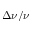<formula> <loc_0><loc_0><loc_500><loc_500>\Delta \nu / \nu</formula> 